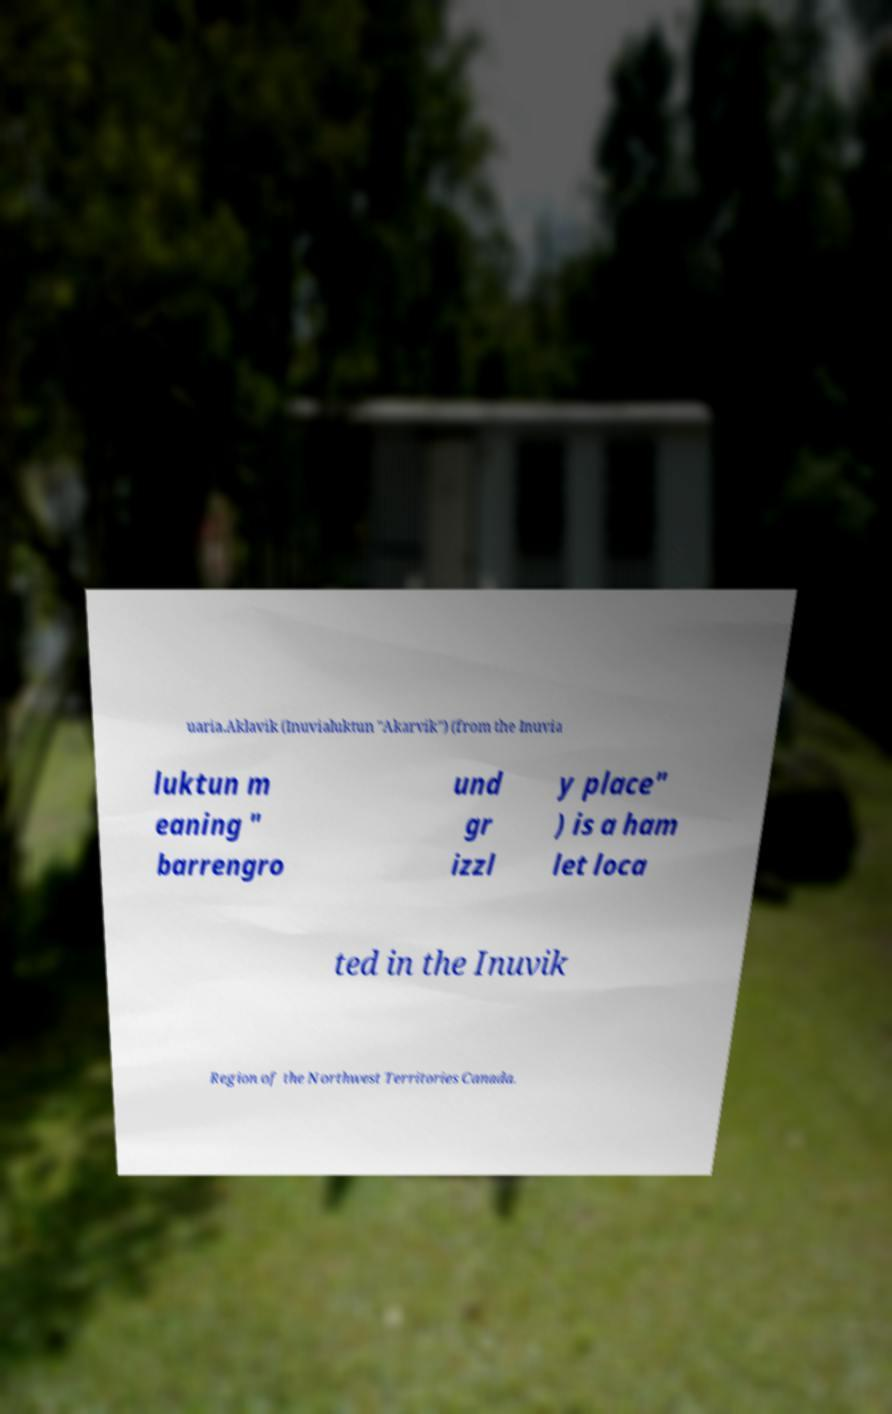Can you read and provide the text displayed in the image?This photo seems to have some interesting text. Can you extract and type it out for me? uaria.Aklavik (Inuvialuktun "Akarvik") (from the Inuvia luktun m eaning " barrengro und gr izzl y place" ) is a ham let loca ted in the Inuvik Region of the Northwest Territories Canada. 